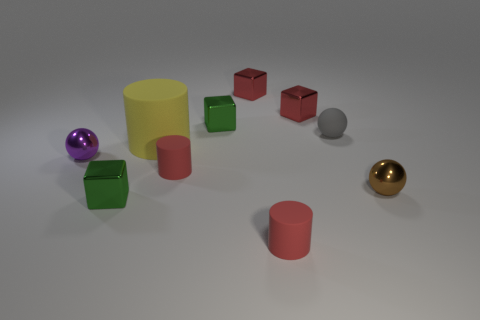Can you tell me about the shapes and their colors in the image? Certainly! There's a purple metallic ball, a green cube-shaped metal block, a red cylindrical rubber object, three red cube-shaped objects possibly made of plastic or rubber, a pink cylindrical object, and a golden metallic ball.  Do the objects appear to have any sort of arrangement or pattern? The objects don't seem to adhere to a strict pattern; however, they are neatly spaced with varying distances between them. The arrangement could suggest a casual display or a mid-step in some sorting or grouping activity.  Is there anything noteworthy about the lighting or shadows? The lighting in the image is soft and diffused, casting gentle shadows under each object. It gives the scene a calm, almost studio-like appearance, indicating the light source is probably artificial and positioned above the objects. 